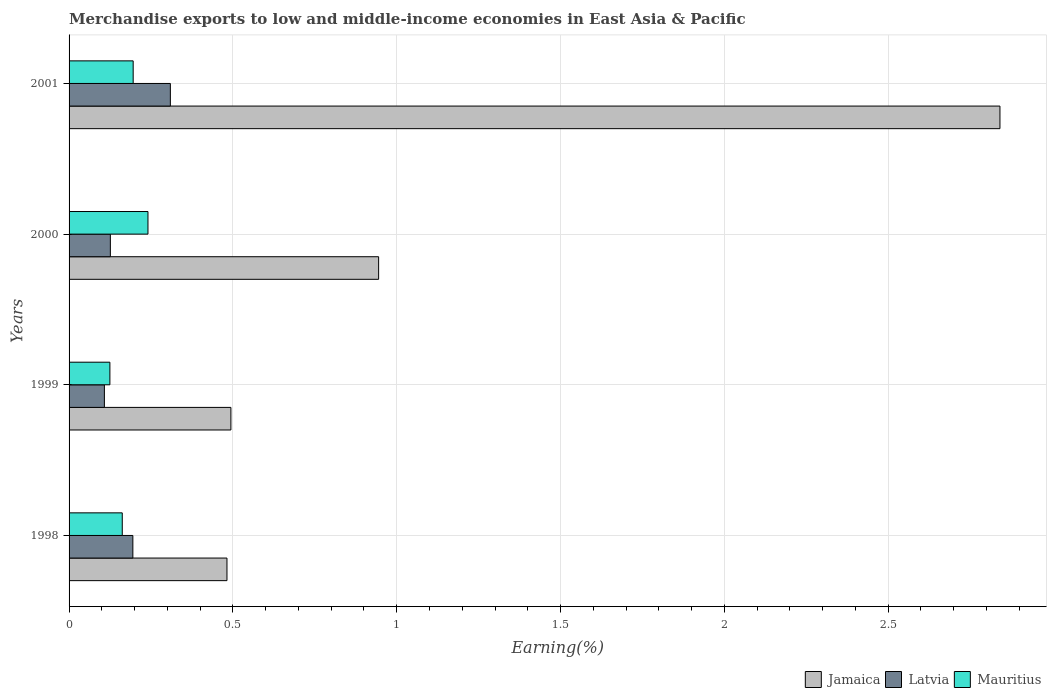How many bars are there on the 3rd tick from the bottom?
Your answer should be compact. 3. What is the label of the 4th group of bars from the top?
Your answer should be very brief. 1998. What is the percentage of amount earned from merchandise exports in Jamaica in 1998?
Give a very brief answer. 0.48. Across all years, what is the maximum percentage of amount earned from merchandise exports in Jamaica?
Your answer should be compact. 2.84. Across all years, what is the minimum percentage of amount earned from merchandise exports in Mauritius?
Keep it short and to the point. 0.12. In which year was the percentage of amount earned from merchandise exports in Jamaica maximum?
Keep it short and to the point. 2001. In which year was the percentage of amount earned from merchandise exports in Latvia minimum?
Your response must be concise. 1999. What is the total percentage of amount earned from merchandise exports in Jamaica in the graph?
Offer a very short reply. 4.76. What is the difference between the percentage of amount earned from merchandise exports in Mauritius in 1999 and that in 2001?
Provide a succinct answer. -0.07. What is the difference between the percentage of amount earned from merchandise exports in Jamaica in 1998 and the percentage of amount earned from merchandise exports in Latvia in 2001?
Provide a succinct answer. 0.17. What is the average percentage of amount earned from merchandise exports in Jamaica per year?
Ensure brevity in your answer.  1.19. In the year 2000, what is the difference between the percentage of amount earned from merchandise exports in Jamaica and percentage of amount earned from merchandise exports in Latvia?
Keep it short and to the point. 0.82. What is the ratio of the percentage of amount earned from merchandise exports in Jamaica in 1999 to that in 2000?
Your answer should be compact. 0.52. Is the difference between the percentage of amount earned from merchandise exports in Jamaica in 1998 and 2001 greater than the difference between the percentage of amount earned from merchandise exports in Latvia in 1998 and 2001?
Give a very brief answer. No. What is the difference between the highest and the second highest percentage of amount earned from merchandise exports in Mauritius?
Provide a succinct answer. 0.05. What is the difference between the highest and the lowest percentage of amount earned from merchandise exports in Latvia?
Give a very brief answer. 0.2. Is the sum of the percentage of amount earned from merchandise exports in Mauritius in 1999 and 2000 greater than the maximum percentage of amount earned from merchandise exports in Jamaica across all years?
Give a very brief answer. No. What does the 2nd bar from the top in 2001 represents?
Your response must be concise. Latvia. What does the 2nd bar from the bottom in 2001 represents?
Your response must be concise. Latvia. Is it the case that in every year, the sum of the percentage of amount earned from merchandise exports in Latvia and percentage of amount earned from merchandise exports in Mauritius is greater than the percentage of amount earned from merchandise exports in Jamaica?
Keep it short and to the point. No. How many years are there in the graph?
Offer a terse response. 4. What is the difference between two consecutive major ticks on the X-axis?
Provide a short and direct response. 0.5. Are the values on the major ticks of X-axis written in scientific E-notation?
Your answer should be compact. No. Does the graph contain any zero values?
Your answer should be compact. No. Where does the legend appear in the graph?
Keep it short and to the point. Bottom right. How many legend labels are there?
Your answer should be compact. 3. What is the title of the graph?
Give a very brief answer. Merchandise exports to low and middle-income economies in East Asia & Pacific. What is the label or title of the X-axis?
Offer a terse response. Earning(%). What is the label or title of the Y-axis?
Offer a very short reply. Years. What is the Earning(%) of Jamaica in 1998?
Give a very brief answer. 0.48. What is the Earning(%) of Latvia in 1998?
Your answer should be compact. 0.19. What is the Earning(%) in Mauritius in 1998?
Keep it short and to the point. 0.16. What is the Earning(%) in Jamaica in 1999?
Provide a succinct answer. 0.49. What is the Earning(%) of Latvia in 1999?
Provide a short and direct response. 0.11. What is the Earning(%) of Mauritius in 1999?
Your answer should be very brief. 0.12. What is the Earning(%) of Jamaica in 2000?
Provide a succinct answer. 0.94. What is the Earning(%) of Latvia in 2000?
Keep it short and to the point. 0.13. What is the Earning(%) of Mauritius in 2000?
Offer a very short reply. 0.24. What is the Earning(%) of Jamaica in 2001?
Make the answer very short. 2.84. What is the Earning(%) in Latvia in 2001?
Offer a terse response. 0.31. What is the Earning(%) in Mauritius in 2001?
Offer a very short reply. 0.2. Across all years, what is the maximum Earning(%) in Jamaica?
Your response must be concise. 2.84. Across all years, what is the maximum Earning(%) in Latvia?
Keep it short and to the point. 0.31. Across all years, what is the maximum Earning(%) in Mauritius?
Give a very brief answer. 0.24. Across all years, what is the minimum Earning(%) of Jamaica?
Provide a succinct answer. 0.48. Across all years, what is the minimum Earning(%) in Latvia?
Make the answer very short. 0.11. Across all years, what is the minimum Earning(%) in Mauritius?
Give a very brief answer. 0.12. What is the total Earning(%) in Jamaica in the graph?
Give a very brief answer. 4.76. What is the total Earning(%) of Latvia in the graph?
Make the answer very short. 0.74. What is the total Earning(%) of Mauritius in the graph?
Make the answer very short. 0.72. What is the difference between the Earning(%) in Jamaica in 1998 and that in 1999?
Offer a very short reply. -0.01. What is the difference between the Earning(%) of Latvia in 1998 and that in 1999?
Provide a short and direct response. 0.09. What is the difference between the Earning(%) of Mauritius in 1998 and that in 1999?
Provide a short and direct response. 0.04. What is the difference between the Earning(%) in Jamaica in 1998 and that in 2000?
Your answer should be very brief. -0.46. What is the difference between the Earning(%) of Latvia in 1998 and that in 2000?
Give a very brief answer. 0.07. What is the difference between the Earning(%) of Mauritius in 1998 and that in 2000?
Provide a short and direct response. -0.08. What is the difference between the Earning(%) in Jamaica in 1998 and that in 2001?
Keep it short and to the point. -2.36. What is the difference between the Earning(%) in Latvia in 1998 and that in 2001?
Keep it short and to the point. -0.11. What is the difference between the Earning(%) in Mauritius in 1998 and that in 2001?
Make the answer very short. -0.03. What is the difference between the Earning(%) in Jamaica in 1999 and that in 2000?
Make the answer very short. -0.45. What is the difference between the Earning(%) of Latvia in 1999 and that in 2000?
Offer a very short reply. -0.02. What is the difference between the Earning(%) of Mauritius in 1999 and that in 2000?
Provide a short and direct response. -0.12. What is the difference between the Earning(%) of Jamaica in 1999 and that in 2001?
Make the answer very short. -2.35. What is the difference between the Earning(%) in Latvia in 1999 and that in 2001?
Keep it short and to the point. -0.2. What is the difference between the Earning(%) in Mauritius in 1999 and that in 2001?
Your response must be concise. -0.07. What is the difference between the Earning(%) in Jamaica in 2000 and that in 2001?
Provide a short and direct response. -1.9. What is the difference between the Earning(%) in Latvia in 2000 and that in 2001?
Your response must be concise. -0.18. What is the difference between the Earning(%) in Mauritius in 2000 and that in 2001?
Provide a succinct answer. 0.05. What is the difference between the Earning(%) in Jamaica in 1998 and the Earning(%) in Latvia in 1999?
Give a very brief answer. 0.37. What is the difference between the Earning(%) in Jamaica in 1998 and the Earning(%) in Mauritius in 1999?
Provide a short and direct response. 0.36. What is the difference between the Earning(%) of Latvia in 1998 and the Earning(%) of Mauritius in 1999?
Offer a terse response. 0.07. What is the difference between the Earning(%) of Jamaica in 1998 and the Earning(%) of Latvia in 2000?
Give a very brief answer. 0.36. What is the difference between the Earning(%) of Jamaica in 1998 and the Earning(%) of Mauritius in 2000?
Give a very brief answer. 0.24. What is the difference between the Earning(%) of Latvia in 1998 and the Earning(%) of Mauritius in 2000?
Ensure brevity in your answer.  -0.05. What is the difference between the Earning(%) in Jamaica in 1998 and the Earning(%) in Latvia in 2001?
Offer a terse response. 0.17. What is the difference between the Earning(%) in Jamaica in 1998 and the Earning(%) in Mauritius in 2001?
Ensure brevity in your answer.  0.29. What is the difference between the Earning(%) in Latvia in 1998 and the Earning(%) in Mauritius in 2001?
Provide a succinct answer. -0. What is the difference between the Earning(%) in Jamaica in 1999 and the Earning(%) in Latvia in 2000?
Give a very brief answer. 0.37. What is the difference between the Earning(%) of Jamaica in 1999 and the Earning(%) of Mauritius in 2000?
Keep it short and to the point. 0.25. What is the difference between the Earning(%) of Latvia in 1999 and the Earning(%) of Mauritius in 2000?
Ensure brevity in your answer.  -0.13. What is the difference between the Earning(%) of Jamaica in 1999 and the Earning(%) of Latvia in 2001?
Ensure brevity in your answer.  0.18. What is the difference between the Earning(%) of Jamaica in 1999 and the Earning(%) of Mauritius in 2001?
Make the answer very short. 0.3. What is the difference between the Earning(%) in Latvia in 1999 and the Earning(%) in Mauritius in 2001?
Give a very brief answer. -0.09. What is the difference between the Earning(%) of Jamaica in 2000 and the Earning(%) of Latvia in 2001?
Give a very brief answer. 0.64. What is the difference between the Earning(%) in Jamaica in 2000 and the Earning(%) in Mauritius in 2001?
Your answer should be very brief. 0.75. What is the difference between the Earning(%) of Latvia in 2000 and the Earning(%) of Mauritius in 2001?
Offer a very short reply. -0.07. What is the average Earning(%) of Jamaica per year?
Give a very brief answer. 1.19. What is the average Earning(%) in Latvia per year?
Make the answer very short. 0.18. What is the average Earning(%) of Mauritius per year?
Provide a succinct answer. 0.18. In the year 1998, what is the difference between the Earning(%) of Jamaica and Earning(%) of Latvia?
Provide a succinct answer. 0.29. In the year 1998, what is the difference between the Earning(%) of Jamaica and Earning(%) of Mauritius?
Offer a very short reply. 0.32. In the year 1998, what is the difference between the Earning(%) of Latvia and Earning(%) of Mauritius?
Give a very brief answer. 0.03. In the year 1999, what is the difference between the Earning(%) of Jamaica and Earning(%) of Latvia?
Offer a terse response. 0.39. In the year 1999, what is the difference between the Earning(%) in Jamaica and Earning(%) in Mauritius?
Offer a terse response. 0.37. In the year 1999, what is the difference between the Earning(%) of Latvia and Earning(%) of Mauritius?
Your response must be concise. -0.02. In the year 2000, what is the difference between the Earning(%) of Jamaica and Earning(%) of Latvia?
Give a very brief answer. 0.82. In the year 2000, what is the difference between the Earning(%) of Jamaica and Earning(%) of Mauritius?
Provide a succinct answer. 0.7. In the year 2000, what is the difference between the Earning(%) in Latvia and Earning(%) in Mauritius?
Offer a very short reply. -0.11. In the year 2001, what is the difference between the Earning(%) of Jamaica and Earning(%) of Latvia?
Provide a short and direct response. 2.53. In the year 2001, what is the difference between the Earning(%) in Jamaica and Earning(%) in Mauritius?
Offer a terse response. 2.65. In the year 2001, what is the difference between the Earning(%) in Latvia and Earning(%) in Mauritius?
Give a very brief answer. 0.11. What is the ratio of the Earning(%) of Jamaica in 1998 to that in 1999?
Provide a succinct answer. 0.98. What is the ratio of the Earning(%) of Latvia in 1998 to that in 1999?
Your answer should be very brief. 1.81. What is the ratio of the Earning(%) in Mauritius in 1998 to that in 1999?
Offer a terse response. 1.3. What is the ratio of the Earning(%) in Jamaica in 1998 to that in 2000?
Provide a succinct answer. 0.51. What is the ratio of the Earning(%) of Latvia in 1998 to that in 2000?
Your answer should be compact. 1.55. What is the ratio of the Earning(%) in Mauritius in 1998 to that in 2000?
Keep it short and to the point. 0.67. What is the ratio of the Earning(%) in Jamaica in 1998 to that in 2001?
Your response must be concise. 0.17. What is the ratio of the Earning(%) of Latvia in 1998 to that in 2001?
Keep it short and to the point. 0.63. What is the ratio of the Earning(%) in Mauritius in 1998 to that in 2001?
Make the answer very short. 0.83. What is the ratio of the Earning(%) of Jamaica in 1999 to that in 2000?
Provide a short and direct response. 0.52. What is the ratio of the Earning(%) of Latvia in 1999 to that in 2000?
Offer a terse response. 0.86. What is the ratio of the Earning(%) of Mauritius in 1999 to that in 2000?
Make the answer very short. 0.52. What is the ratio of the Earning(%) of Jamaica in 1999 to that in 2001?
Provide a short and direct response. 0.17. What is the ratio of the Earning(%) in Latvia in 1999 to that in 2001?
Ensure brevity in your answer.  0.35. What is the ratio of the Earning(%) of Mauritius in 1999 to that in 2001?
Offer a very short reply. 0.64. What is the ratio of the Earning(%) in Jamaica in 2000 to that in 2001?
Provide a succinct answer. 0.33. What is the ratio of the Earning(%) of Latvia in 2000 to that in 2001?
Give a very brief answer. 0.41. What is the ratio of the Earning(%) in Mauritius in 2000 to that in 2001?
Make the answer very short. 1.23. What is the difference between the highest and the second highest Earning(%) in Jamaica?
Your answer should be very brief. 1.9. What is the difference between the highest and the second highest Earning(%) of Latvia?
Offer a very short reply. 0.11. What is the difference between the highest and the second highest Earning(%) in Mauritius?
Your response must be concise. 0.05. What is the difference between the highest and the lowest Earning(%) of Jamaica?
Offer a very short reply. 2.36. What is the difference between the highest and the lowest Earning(%) in Latvia?
Keep it short and to the point. 0.2. What is the difference between the highest and the lowest Earning(%) in Mauritius?
Provide a short and direct response. 0.12. 